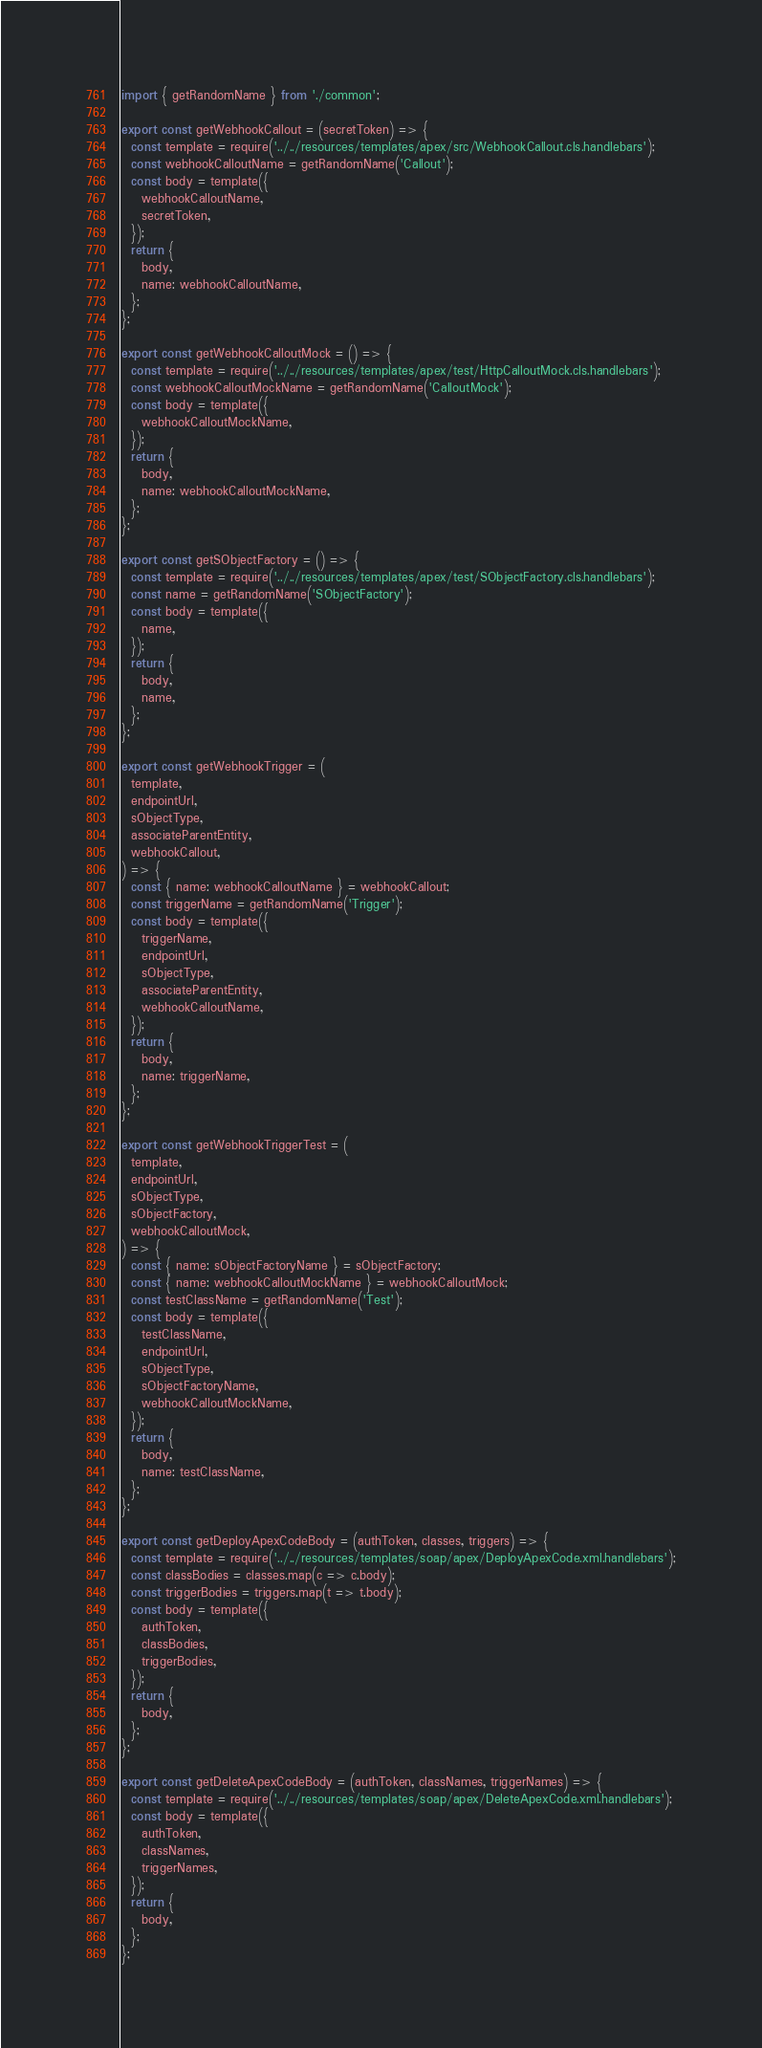Convert code to text. <code><loc_0><loc_0><loc_500><loc_500><_JavaScript_>import { getRandomName } from './common';

export const getWebhookCallout = (secretToken) => {
  const template = require('../../resources/templates/apex/src/WebhookCallout.cls.handlebars');
  const webhookCalloutName = getRandomName('Callout');
  const body = template({
    webhookCalloutName,
    secretToken,
  });
  return {
    body,
    name: webhookCalloutName,
  };
};

export const getWebhookCalloutMock = () => {
  const template = require('../../resources/templates/apex/test/HttpCalloutMock.cls.handlebars');
  const webhookCalloutMockName = getRandomName('CalloutMock');
  const body = template({
    webhookCalloutMockName,
  });
  return {
    body,
    name: webhookCalloutMockName,
  };
};

export const getSObjectFactory = () => {
  const template = require('../../resources/templates/apex/test/SObjectFactory.cls.handlebars');
  const name = getRandomName('SObjectFactory');
  const body = template({
    name,
  });
  return {
    body,
    name,
  };
};

export const getWebhookTrigger = (
  template,
  endpointUrl,
  sObjectType,
  associateParentEntity,
  webhookCallout,
) => {
  const { name: webhookCalloutName } = webhookCallout;
  const triggerName = getRandomName('Trigger');
  const body = template({
    triggerName,
    endpointUrl,
    sObjectType,
    associateParentEntity,
    webhookCalloutName,
  });
  return {
    body,
    name: triggerName,
  };
};

export const getWebhookTriggerTest = (
  template,
  endpointUrl,
  sObjectType,
  sObjectFactory,
  webhookCalloutMock,
) => {
  const { name: sObjectFactoryName } = sObjectFactory;
  const { name: webhookCalloutMockName } = webhookCalloutMock;
  const testClassName = getRandomName('Test');
  const body = template({
    testClassName,
    endpointUrl,
    sObjectType,
    sObjectFactoryName,
    webhookCalloutMockName,
  });
  return {
    body,
    name: testClassName,
  };
};

export const getDeployApexCodeBody = (authToken, classes, triggers) => {
  const template = require('../../resources/templates/soap/apex/DeployApexCode.xml.handlebars');
  const classBodies = classes.map(c => c.body);
  const triggerBodies = triggers.map(t => t.body);
  const body = template({
    authToken,
    classBodies,
    triggerBodies,
  });
  return {
    body,
  };
};

export const getDeleteApexCodeBody = (authToken, classNames, triggerNames) => {
  const template = require('../../resources/templates/soap/apex/DeleteApexCode.xml.handlebars');
  const body = template({
    authToken,
    classNames,
    triggerNames,
  });
  return {
    body,
  };
};
</code> 